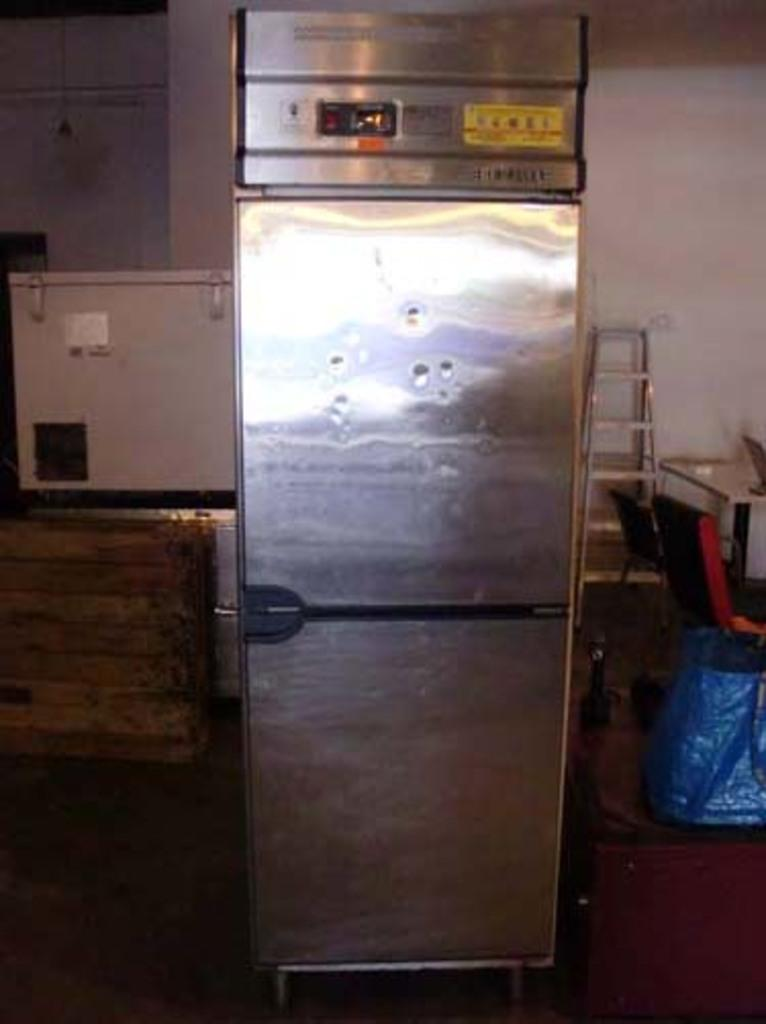<image>
Render a clear and concise summary of the photo. A light on the front of an appliance says -1 